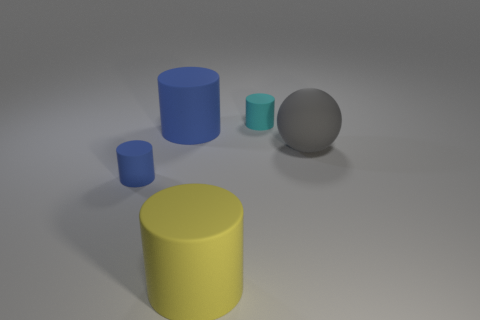How many balls are either tiny cyan rubber things or small things?
Your response must be concise. 0. Is the yellow thing made of the same material as the big gray thing?
Provide a succinct answer. Yes. What is the size of the cyan thing that is the same shape as the yellow object?
Offer a terse response. Small. What material is the object that is both behind the yellow object and in front of the big matte sphere?
Your answer should be very brief. Rubber. Are there the same number of tiny blue things that are behind the gray rubber object and large blue rubber things?
Offer a very short reply. No. What number of things are matte cylinders in front of the small blue rubber cylinder or large gray objects?
Keep it short and to the point. 2. What is the size of the object that is on the right side of the cyan object?
Provide a succinct answer. Large. There is a tiny cyan thing behind the tiny matte cylinder in front of the tiny cyan thing; what shape is it?
Offer a terse response. Cylinder. What color is the other large rubber thing that is the same shape as the large yellow matte thing?
Your response must be concise. Blue. Is the size of the matte object that is right of the cyan cylinder the same as the tiny cyan matte cylinder?
Offer a very short reply. No. 